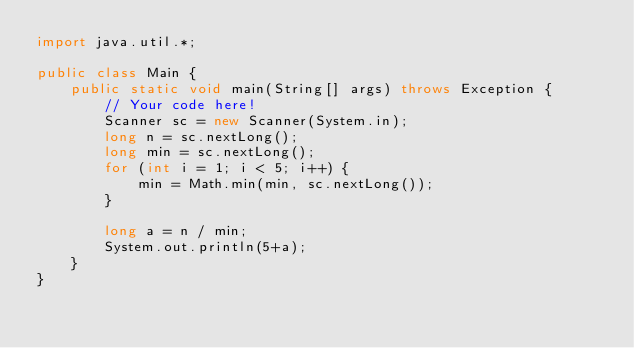<code> <loc_0><loc_0><loc_500><loc_500><_Java_>import java.util.*;

public class Main {
    public static void main(String[] args) throws Exception {
        // Your code here!
        Scanner sc = new Scanner(System.in);
        long n = sc.nextLong();
        long min = sc.nextLong();
        for (int i = 1; i < 5; i++) {
            min = Math.min(min, sc.nextLong());
        }
        
        long a = n / min;
        System.out.println(5+a);
    }
}
</code> 